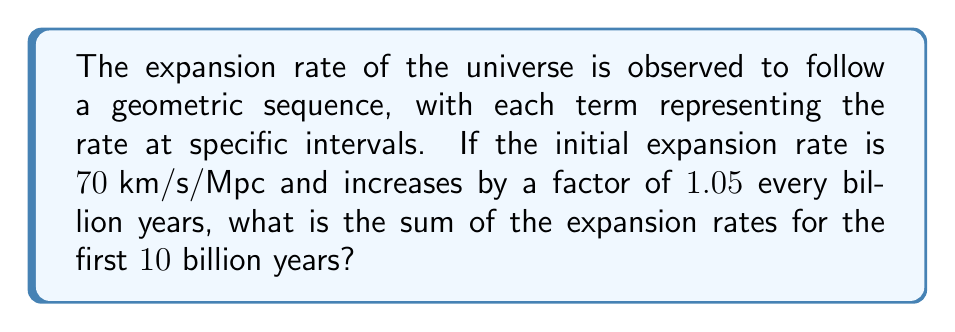Can you solve this math problem? Let's approach this step-by-step:

1) We have a geometric sequence where:
   $a_1 = 70 \text{ km/s/Mpc}$ (first term)
   $r = 1.05$ (common ratio)
   $n = 10$ (number of terms)

2) The formula for the sum of a geometric sequence is:
   $$S_n = \frac{a_1(1-r^n)}{1-r}$$
   where $S_n$ is the sum of $n$ terms.

3) Let's substitute our values:
   $$S_{10} = \frac{70(1-1.05^{10})}{1-1.05}$$

4) Calculate $1.05^{10}$:
   $1.05^{10} \approx 1.6288946267$

5) Substitute this value:
   $$S_{10} = \frac{70(1-1.6288946267)}{1-1.05}$$

6) Simplify the numerator:
   $$S_{10} = \frac{70(-0.6288946267)}{-0.05}$$

7) Perform the division:
   $$S_{10} = 880.45247738 \text{ km/s/Mpc}$$

8) Round to two decimal places:
   $$S_{10} \approx 880.45 \text{ km/s/Mpc}$$
Answer: $880.45 \text{ km/s/Mpc}$ 